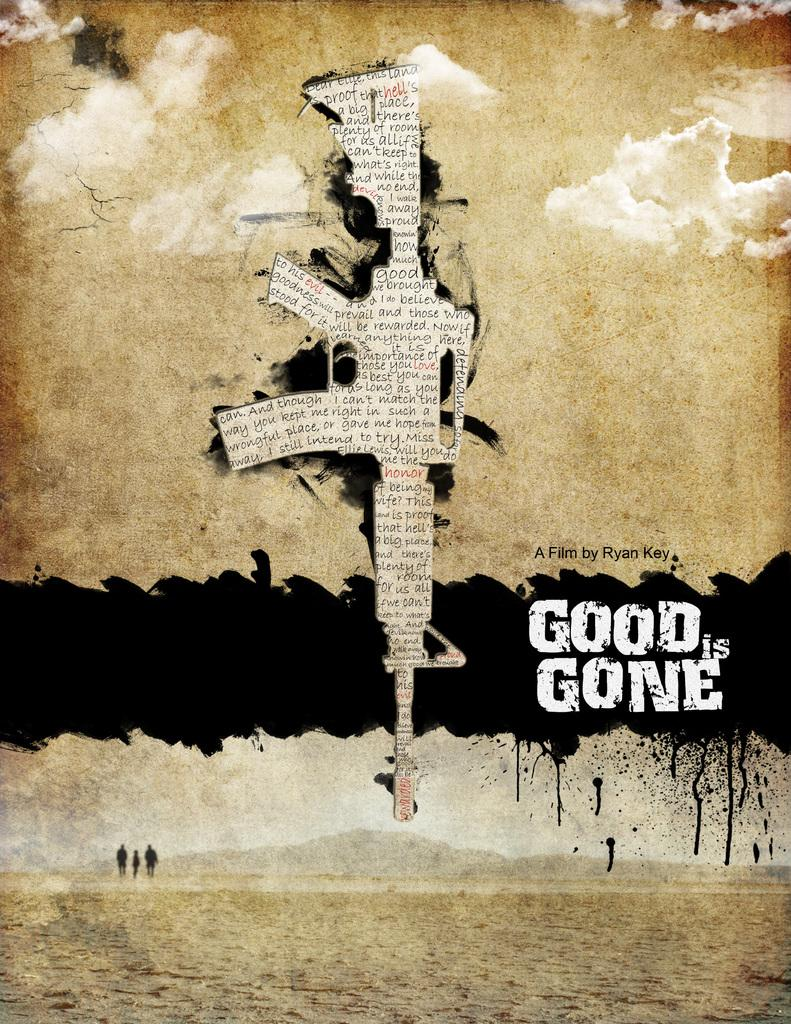<image>
Describe the image concisely. A poster for a film called Good is Gone by Ryan Key shows a rifle and people walking in a desert. 